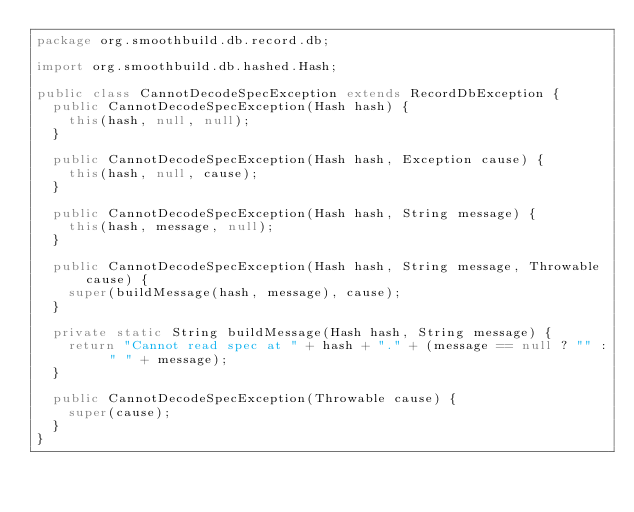<code> <loc_0><loc_0><loc_500><loc_500><_Java_>package org.smoothbuild.db.record.db;

import org.smoothbuild.db.hashed.Hash;

public class CannotDecodeSpecException extends RecordDbException {
  public CannotDecodeSpecException(Hash hash) {
    this(hash, null, null);
  }

  public CannotDecodeSpecException(Hash hash, Exception cause) {
    this(hash, null, cause);
  }

  public CannotDecodeSpecException(Hash hash, String message) {
    this(hash, message, null);
  }

  public CannotDecodeSpecException(Hash hash, String message, Throwable cause) {
    super(buildMessage(hash, message), cause);
  }

  private static String buildMessage(Hash hash, String message) {
    return "Cannot read spec at " + hash + "." + (message == null ? "" : " " + message);
  }

  public CannotDecodeSpecException(Throwable cause) {
    super(cause);
  }
}
</code> 